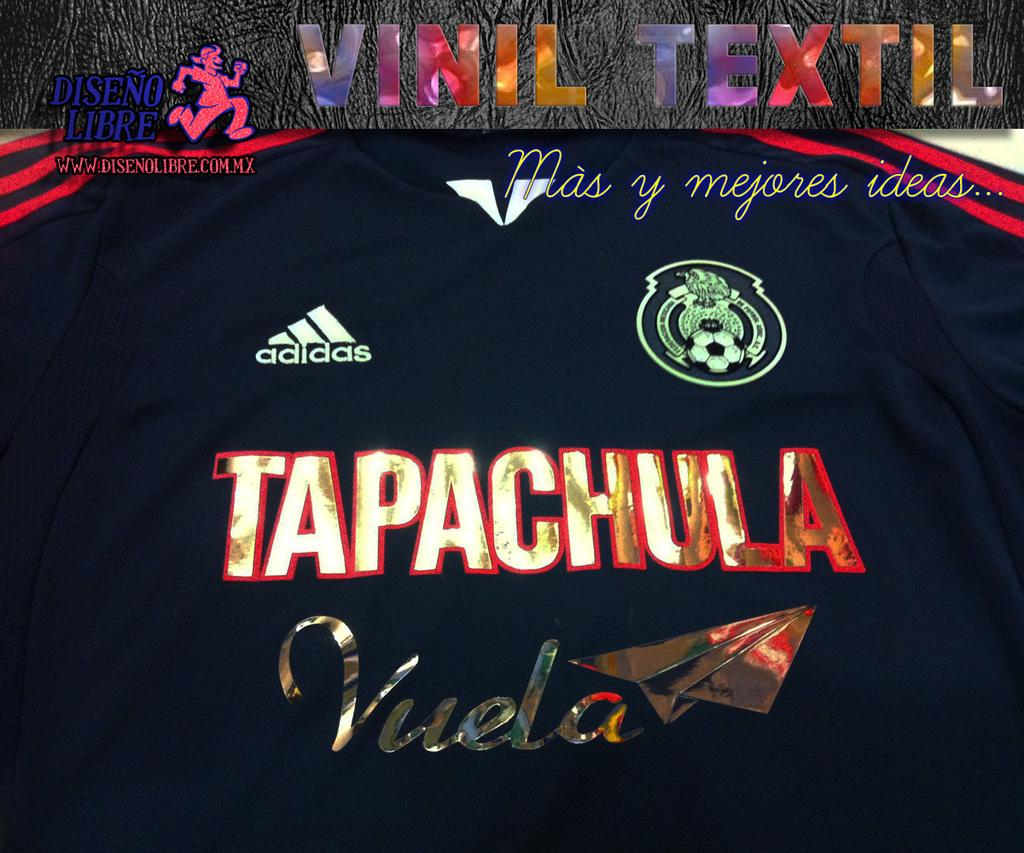<image>
Present a compact description of the photo's key features. The event is sponsored by the company Adidas 